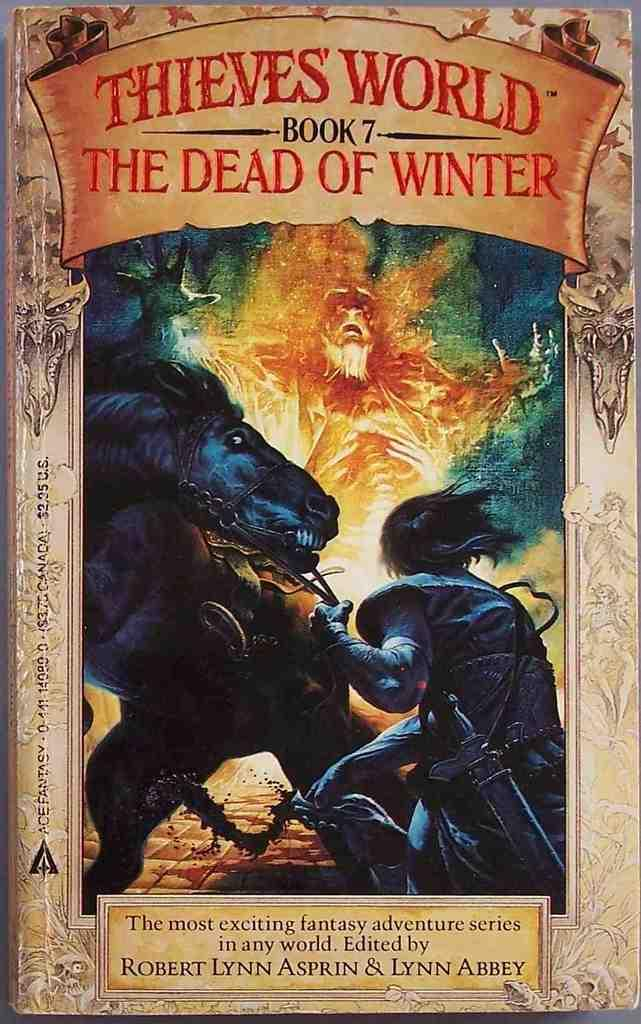<image>
Present a compact description of the photo's key features. Here we have a book cover for book 7 in the Thieves World series titled The Dead of Winter. 